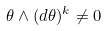Convert formula to latex. <formula><loc_0><loc_0><loc_500><loc_500>\theta \wedge { ( d \theta ) ^ { k } } \neq { 0 }</formula> 